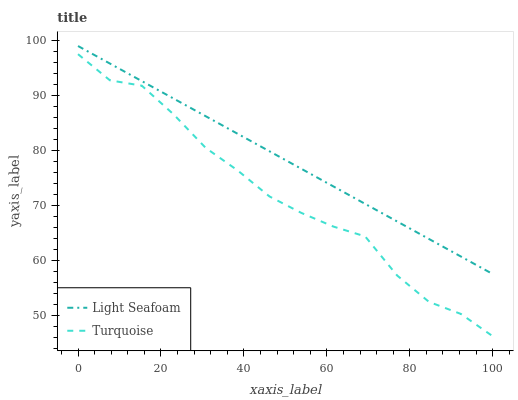Does Turquoise have the minimum area under the curve?
Answer yes or no. Yes. Does Light Seafoam have the maximum area under the curve?
Answer yes or no. Yes. Does Light Seafoam have the minimum area under the curve?
Answer yes or no. No. Is Light Seafoam the smoothest?
Answer yes or no. Yes. Is Turquoise the roughest?
Answer yes or no. Yes. Is Light Seafoam the roughest?
Answer yes or no. No. Does Light Seafoam have the lowest value?
Answer yes or no. No. Does Light Seafoam have the highest value?
Answer yes or no. Yes. Is Turquoise less than Light Seafoam?
Answer yes or no. Yes. Is Light Seafoam greater than Turquoise?
Answer yes or no. Yes. Does Turquoise intersect Light Seafoam?
Answer yes or no. No. 